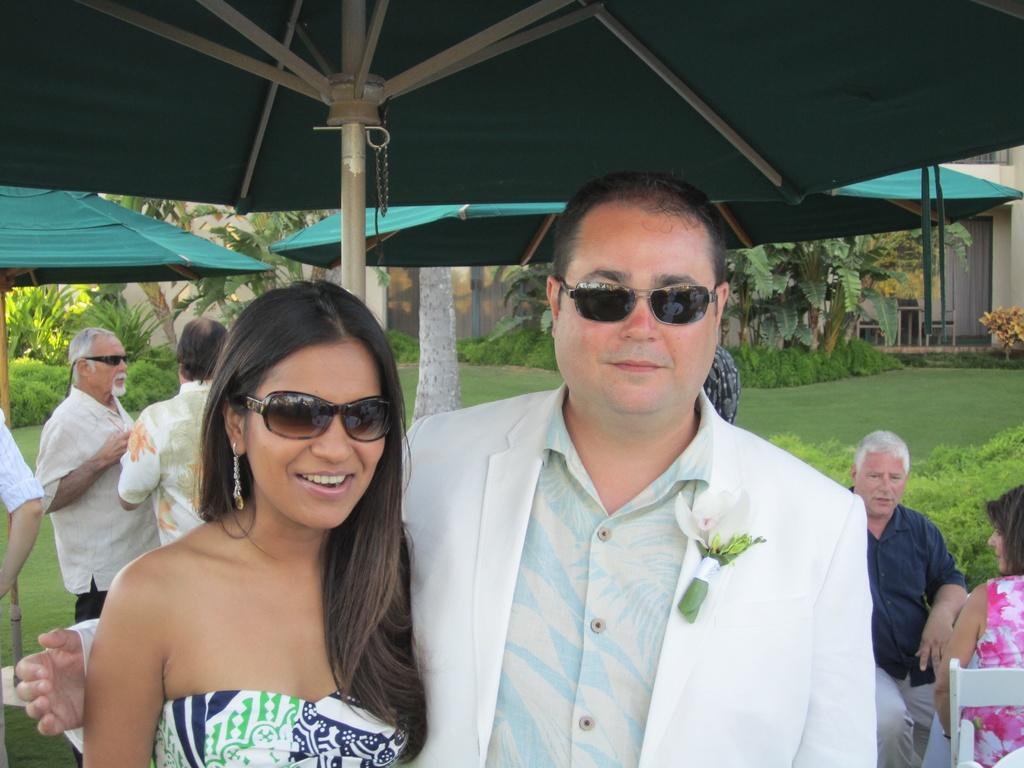In one or two sentences, can you explain what this image depicts? In this image in the foreground there is one man and one woman standing, and they are wearing goggles. And in the background there are some people standing, and some of them are sitting and also there are some umbrellas and poles. In the background there are some plants, grass and building. 